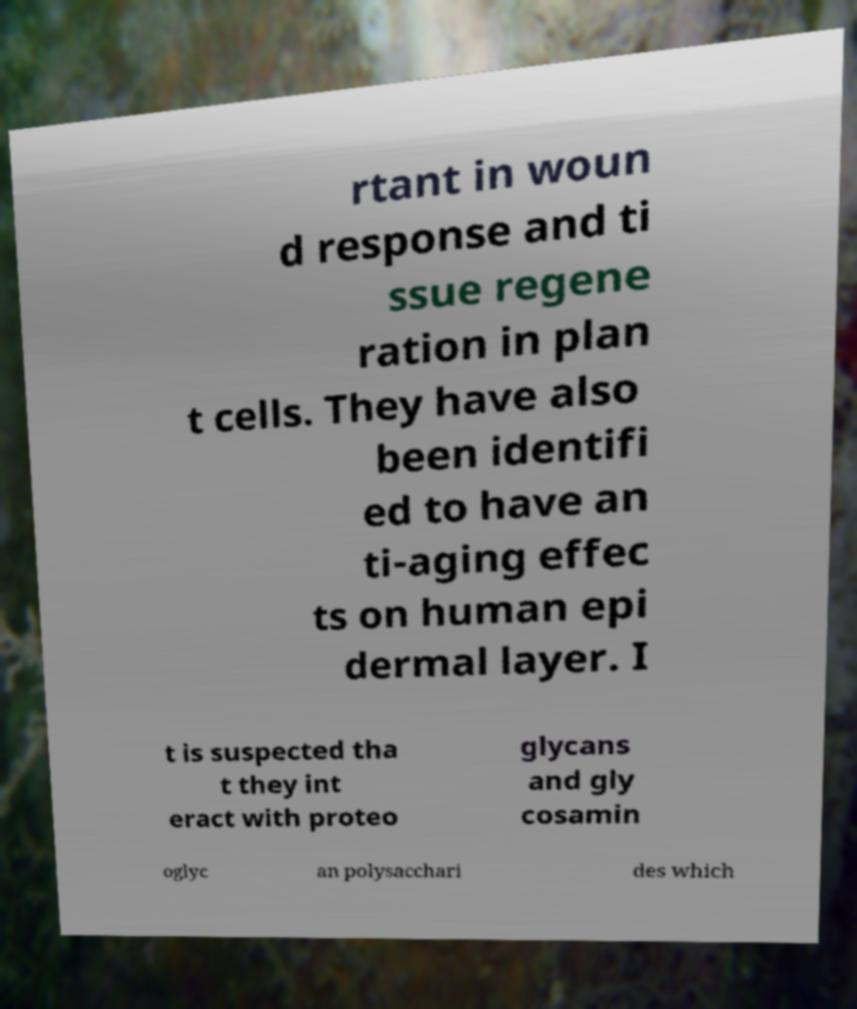Could you assist in decoding the text presented in this image and type it out clearly? rtant in woun d response and ti ssue regene ration in plan t cells. They have also been identifi ed to have an ti-aging effec ts on human epi dermal layer. I t is suspected tha t they int eract with proteo glycans and gly cosamin oglyc an polysacchari des which 